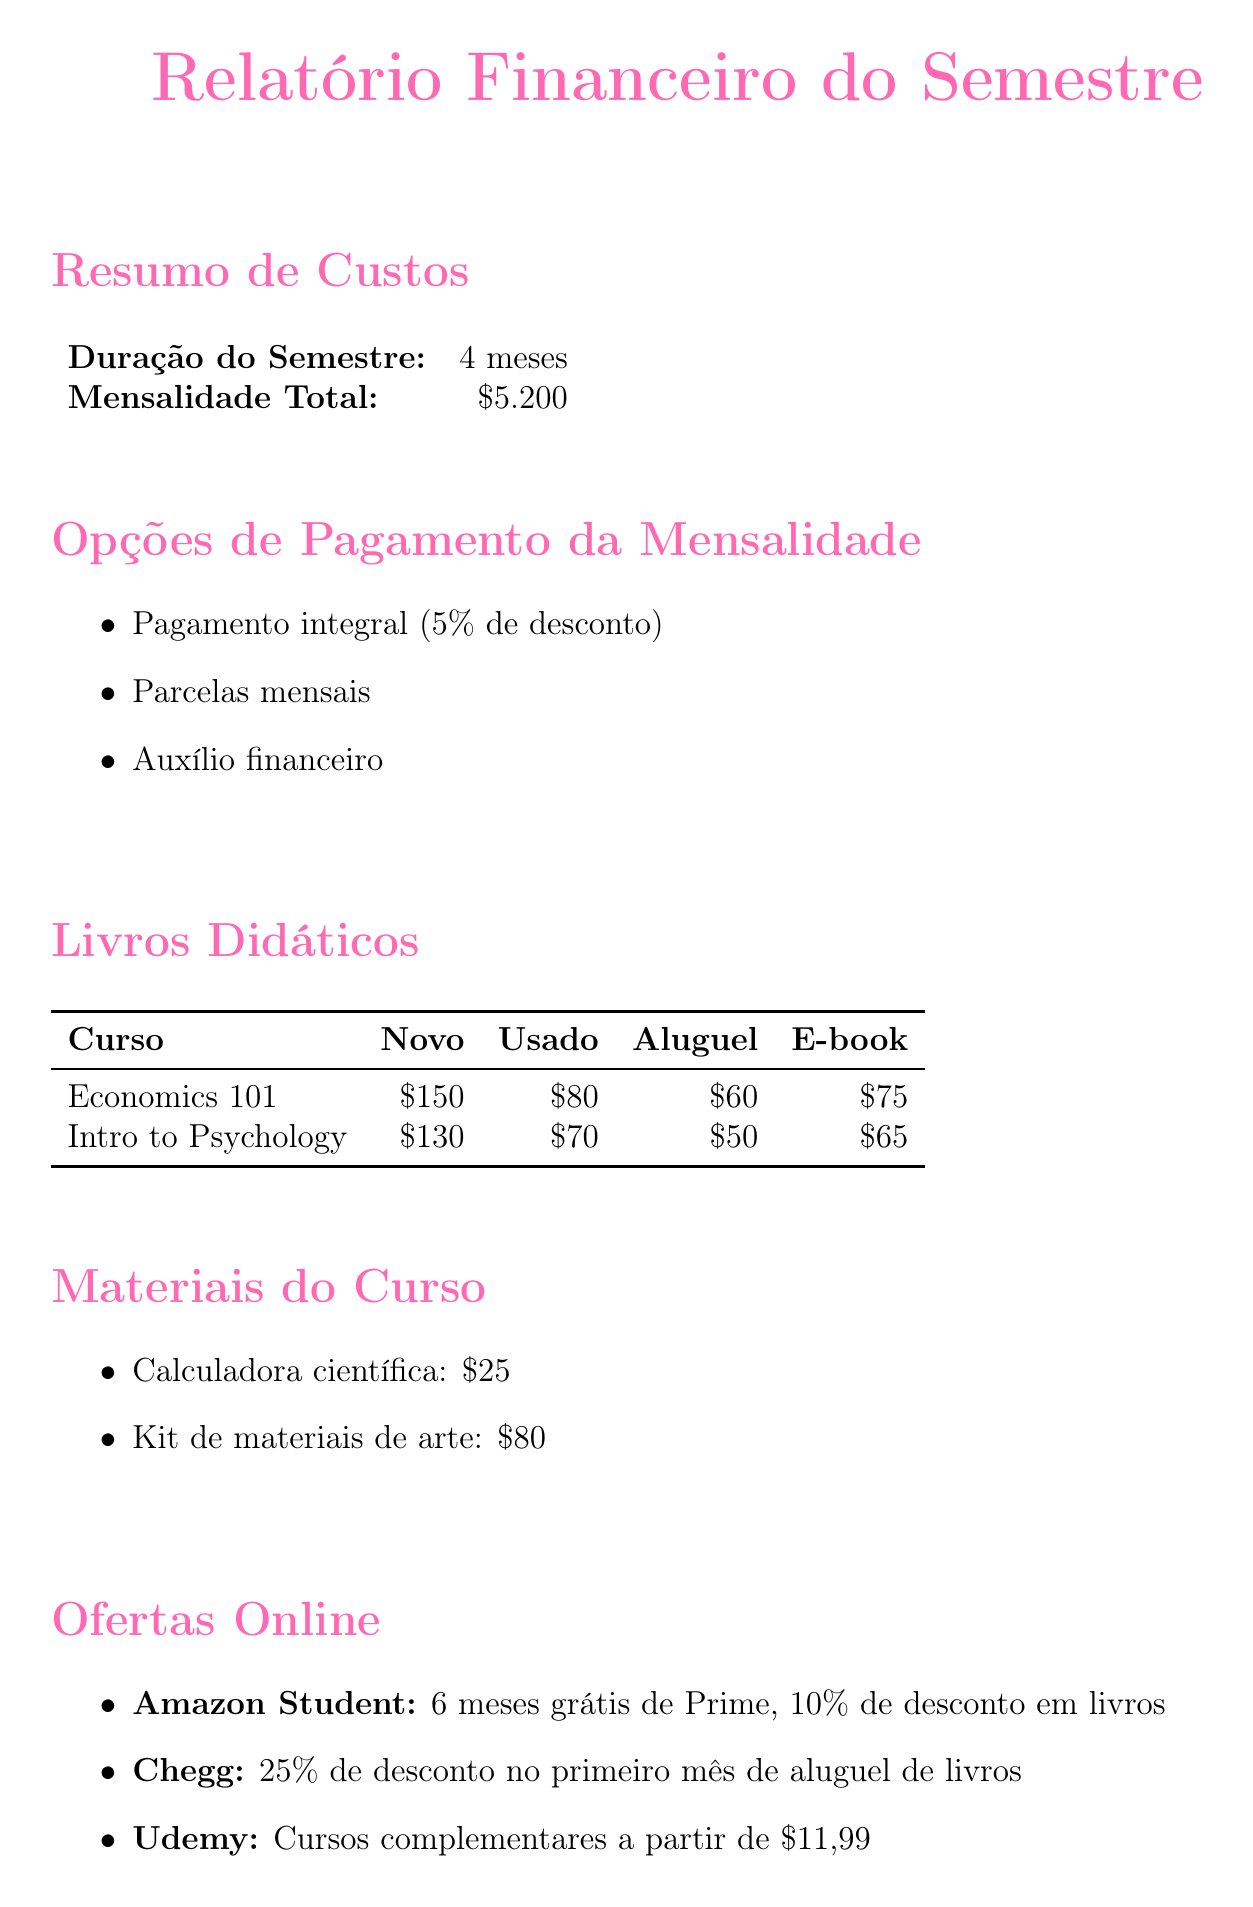Qual é a duração do semestre? A duração do semestre é mencionada como 4 meses na seção Resumo de Custos.
Answer: 4 meses Qual é o custo total da mensalidade? O custo total da mensalidade é listado como $5,200 na seção Resumo de Custos.
Answer: $5,200 Quais são as opções de pagamento da mensalidade? As opções de pagamento estão listadas na seção Opções de Pagamento da Mensalidade.
Answer: Pagamento integral (5% de desconto), Parcelas mensais, Auxílio financeiro Quanto custa alugar o livro "Principles of Economics"? O preço de aluguel do livro é mencionado na tabela de Livros Didáticos.
Answer: $60 Qual é a primeira oferta da plataforma Amazon Student? A primeira oferta da Amazon Student é apresentada na seção Ofertas Online.
Answer: 6 meses grátis de Prime, 10% de desconto em livros Quantos cursos complementares estão disponíveis na Udemy a partir de qual preço? O preço dos cursos complementares na Udemy está mencionado na seção Ofertas Online.
Answer: a partir de $11.99 Qual é o custo do seguro de laptop? O custo do seguro do laptop é listado na seção Despesas Adicionais.
Answer: $50 por semestre Qual é a dica de economia apresentada no documento? A dica de economia é fornecida na seção final do documento onde uma dica é destacada.
Answer: Considere alugar livros ou comprar e-books para economizar! 